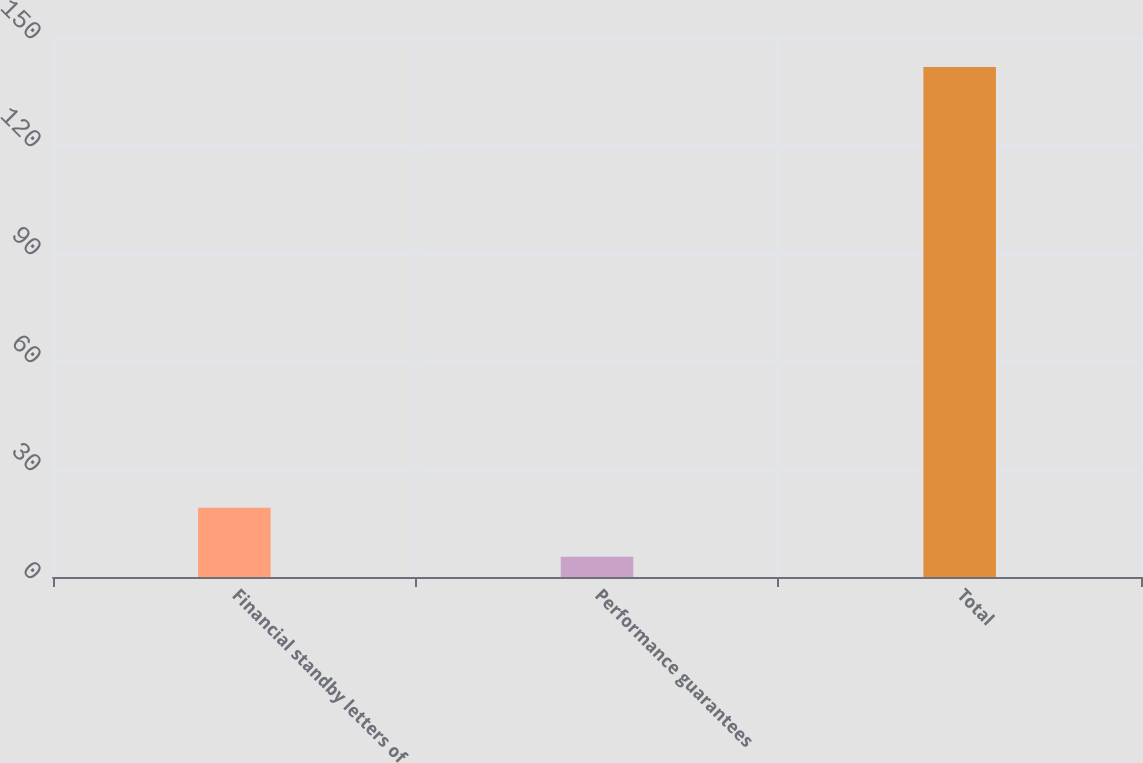Convert chart. <chart><loc_0><loc_0><loc_500><loc_500><bar_chart><fcel>Financial standby letters of<fcel>Performance guarantees<fcel>Total<nl><fcel>19.21<fcel>5.6<fcel>141.7<nl></chart> 